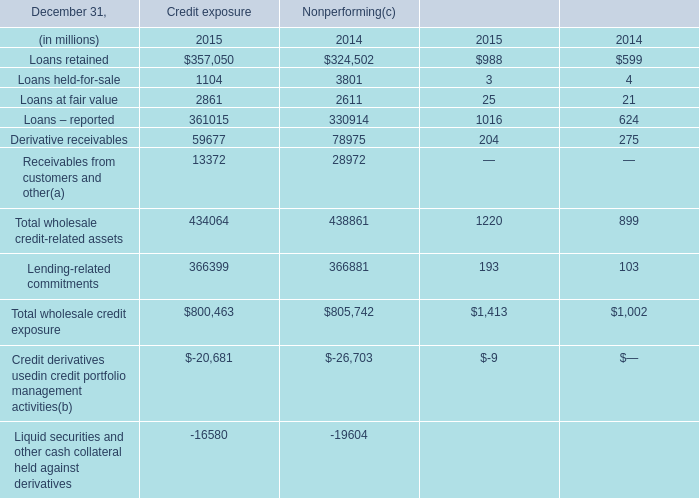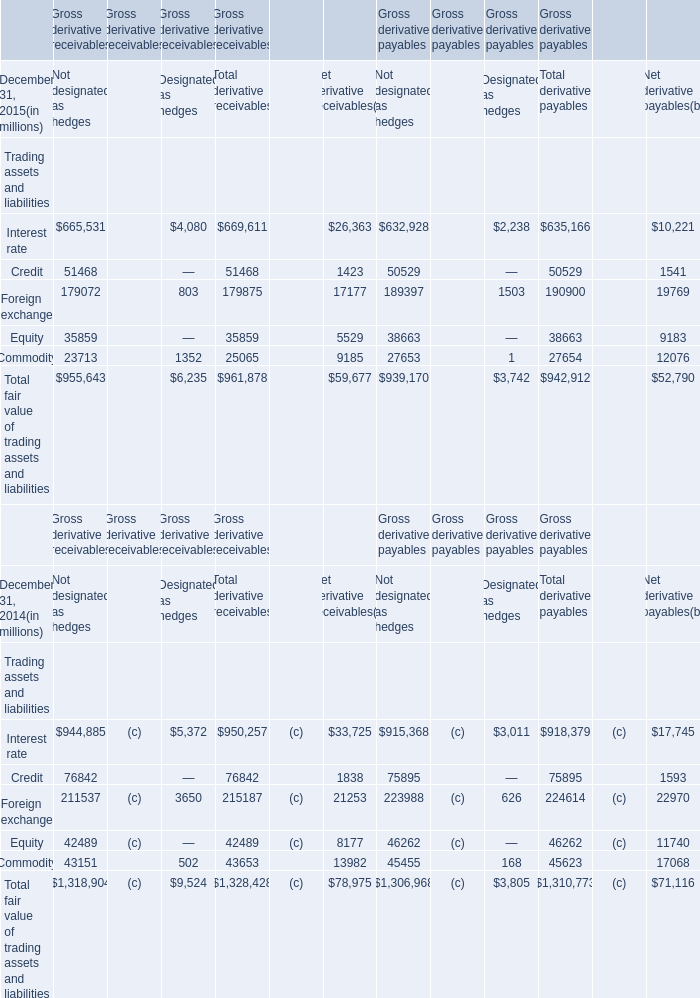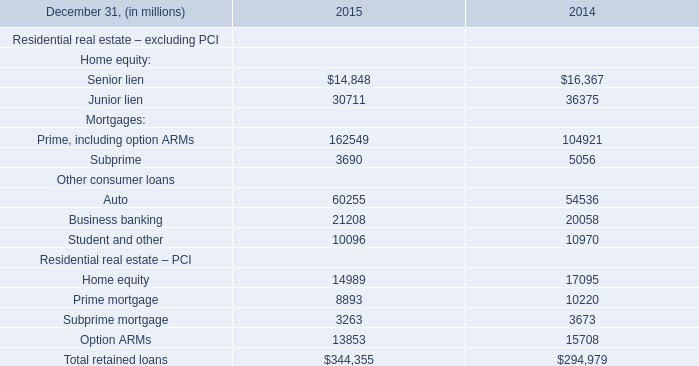What's the sum of all Trading assets and liabilities that are positive in 2015? (in million) 
Computations: (961878 + 942912)
Answer: 1904790.0. 